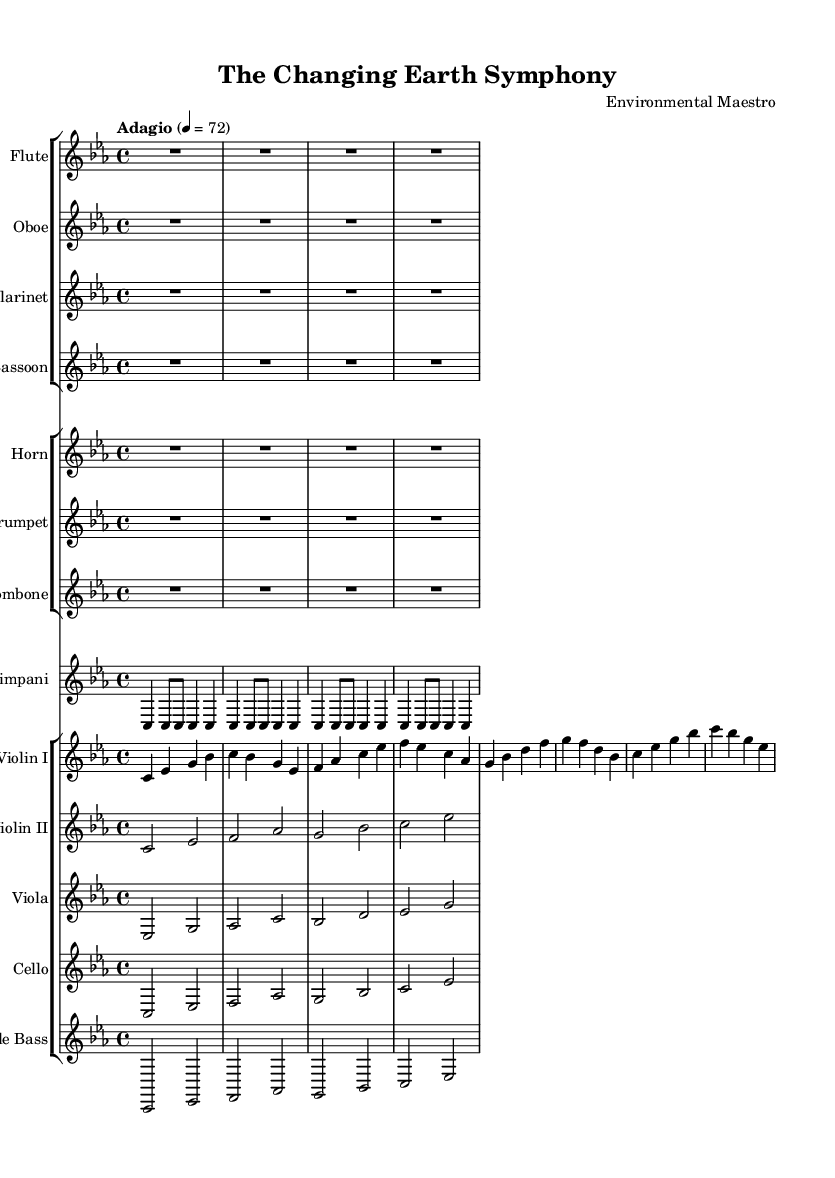What is the key signature of this symphony? The key signature is C minor, which is indicated by the presence of three flats (B flat, E flat, and A flat) at the beginning of the staff.
Answer: C minor What is the time signature of this symphony? The time signature is 4/4, which is shown at the beginning of the staffs and signifies four beats per measure.
Answer: 4/4 What is the tempo marking of this symphony? The tempo marking is "Adagio," which indicates a slow pace, typically around 66 to 76 beats per minute. In this case, it’s set at 72.
Answer: Adagio Which instruments have rests for the entire piece? The flute, oboe, clarinet, and bassoon all have whole rests for the entire duration of the symphony, indicating silence from these instruments throughout.
Answer: Flute, Oboe, Clarinet, Bassoon How many measures are in the violin I part? The violin I part has four measures, each containing four beats, as indicated by the notation displayed across the lines of the staff.
Answer: 4 What does the timpani play, and how is it structured? The timpani plays a repeating rhythmic pattern consisting of the note C, structured in a way that divides the beats into a combination of quarter and eighth notes, reflecting a steady pulse.
Answer: C Which section of the symphony features the most instruments? The string section, which includes Violin I, Violin II, Viola, Cello, and Double Bass, contains the most instruments, totaling five players.
Answer: String section 